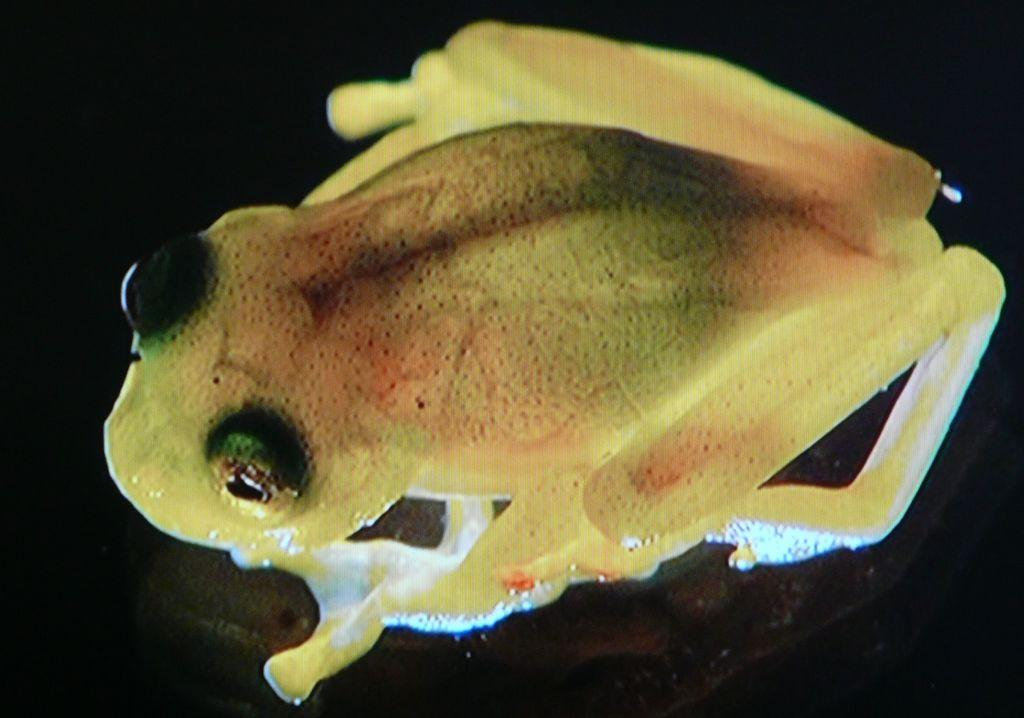What animal is present in the image? There is a frog in the image. What colors can be seen on the frog? The frog has yellow, green, and red colors. What is the background or surface on which the frog is sitting? The frog is on a black surface. Can you see a horn on the frog's head in the image? No, there is no horn present on the frog's head in the image. 